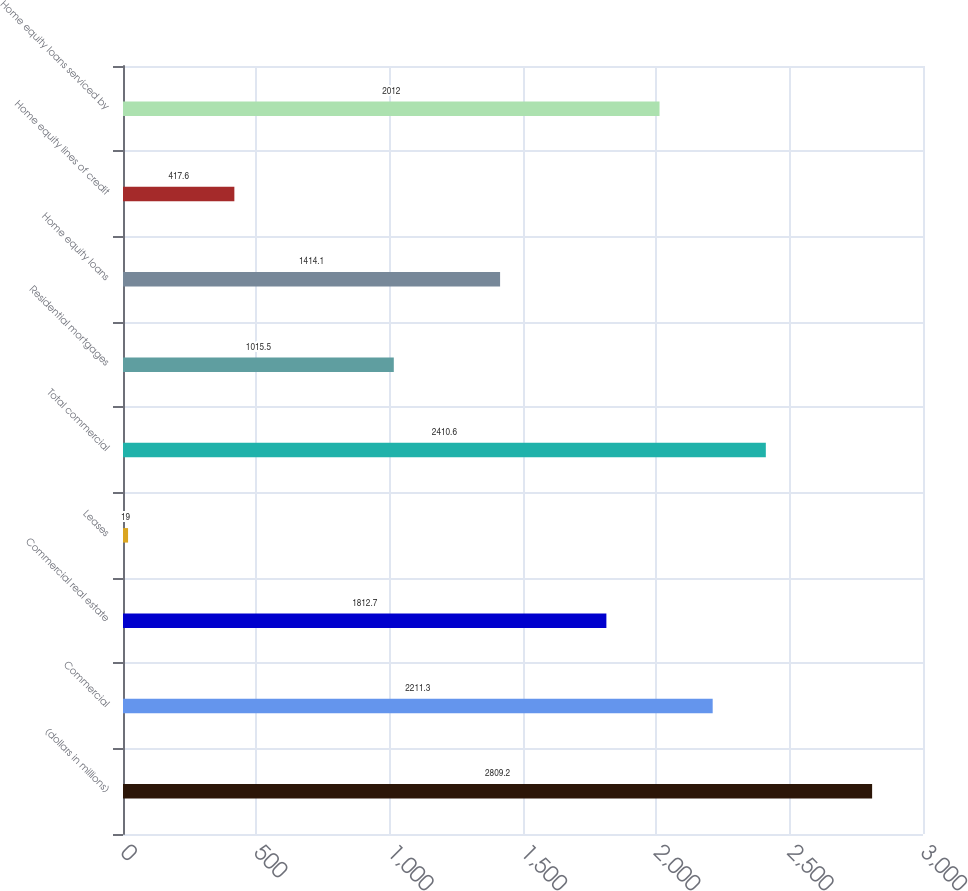Convert chart. <chart><loc_0><loc_0><loc_500><loc_500><bar_chart><fcel>(dollars in millions)<fcel>Commercial<fcel>Commercial real estate<fcel>Leases<fcel>Total commercial<fcel>Residential mortgages<fcel>Home equity loans<fcel>Home equity lines of credit<fcel>Home equity loans serviced by<nl><fcel>2809.2<fcel>2211.3<fcel>1812.7<fcel>19<fcel>2410.6<fcel>1015.5<fcel>1414.1<fcel>417.6<fcel>2012<nl></chart> 